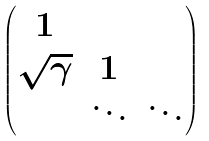Convert formula to latex. <formula><loc_0><loc_0><loc_500><loc_500>\begin{pmatrix} 1 \\ \sqrt { \gamma } & 1 \\ & \ddots & \ddots \\ \end{pmatrix}</formula> 